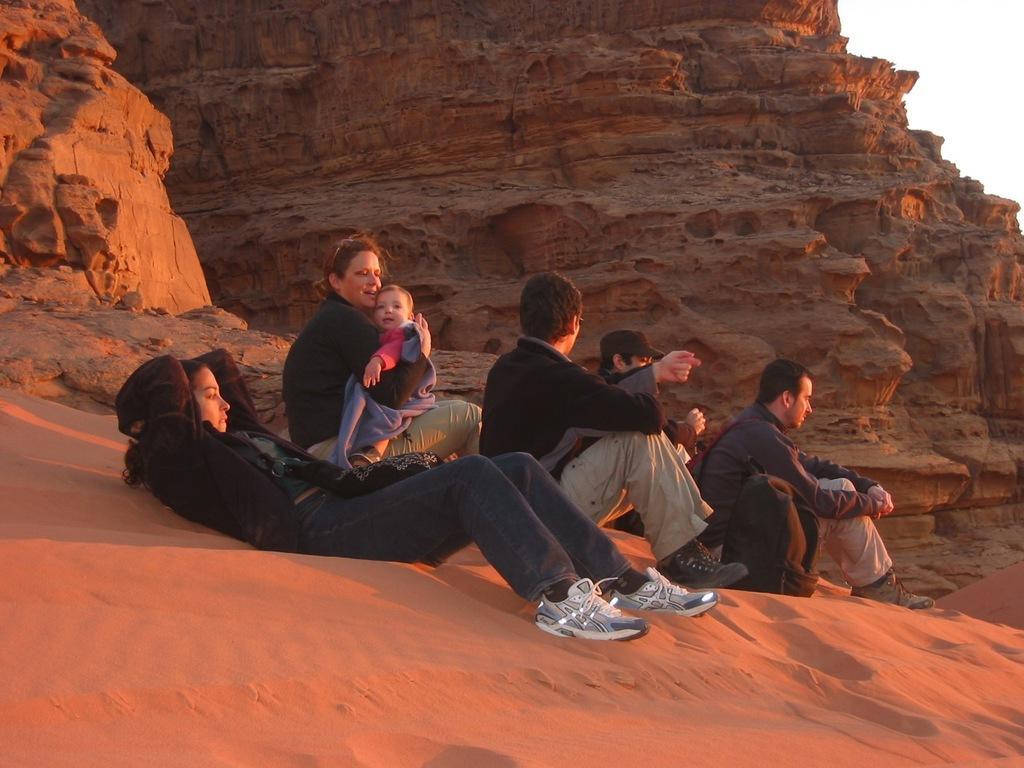Could you give a brief overview of what you see in this image? This picture is taken from outside of the city. In this image, in the middle, we can see a group of people sitting on the sand. In the middle, we can also see a person lying on the sand. In the background, we can see some rocks. On the right side, we can also see white color, at the bottom, we can see a sand. 